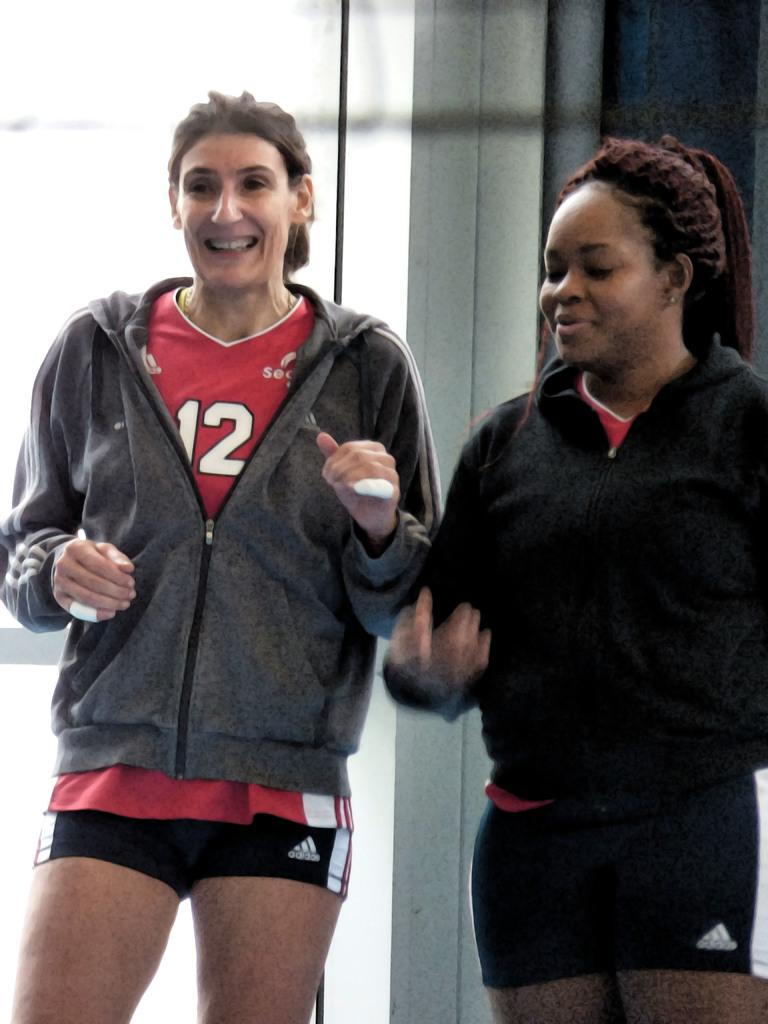<image>
Share a concise interpretation of the image provided. A woman wears an athletic shirt with the number 12 on it. 